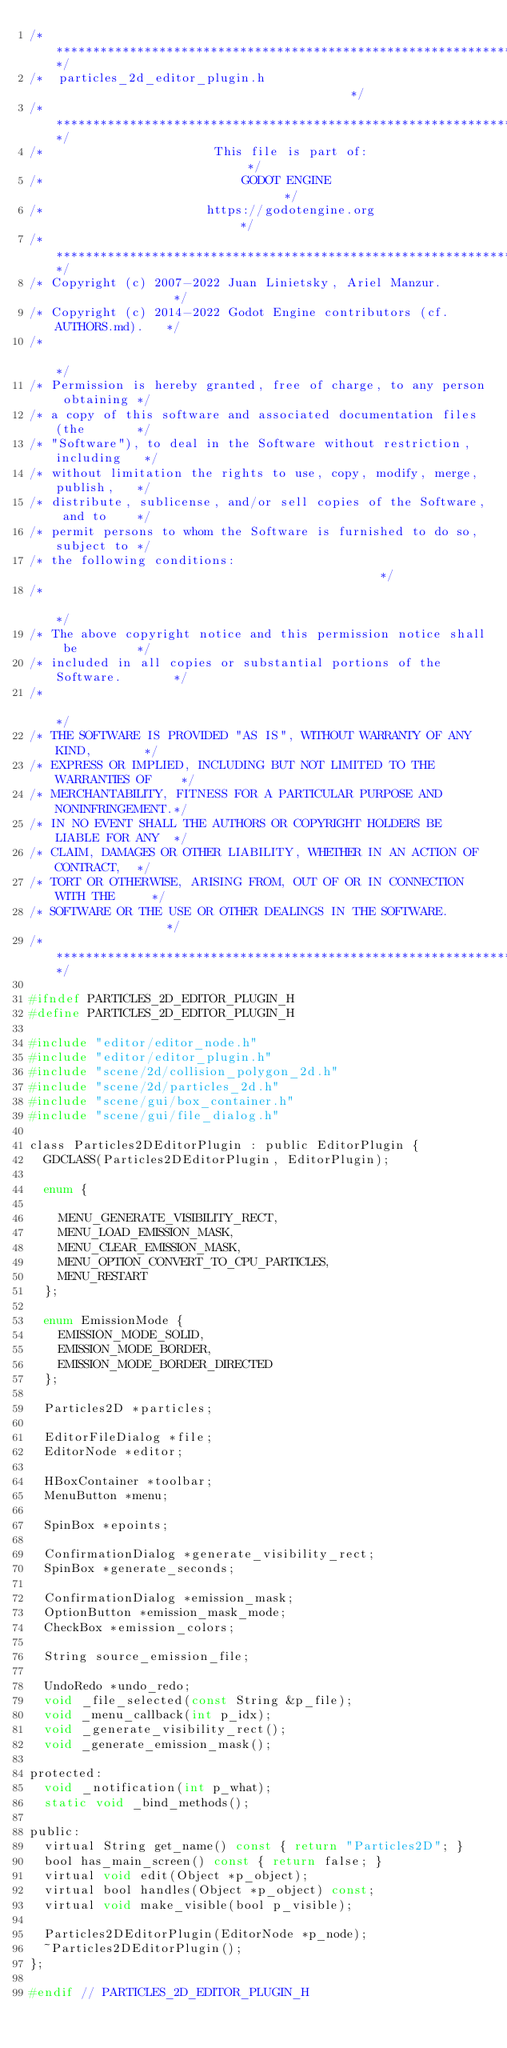Convert code to text. <code><loc_0><loc_0><loc_500><loc_500><_C_>/*************************************************************************/
/*  particles_2d_editor_plugin.h                                         */
/*************************************************************************/
/*                       This file is part of:                           */
/*                           GODOT ENGINE                                */
/*                      https://godotengine.org                          */
/*************************************************************************/
/* Copyright (c) 2007-2022 Juan Linietsky, Ariel Manzur.                 */
/* Copyright (c) 2014-2022 Godot Engine contributors (cf. AUTHORS.md).   */
/*                                                                       */
/* Permission is hereby granted, free of charge, to any person obtaining */
/* a copy of this software and associated documentation files (the       */
/* "Software"), to deal in the Software without restriction, including   */
/* without limitation the rights to use, copy, modify, merge, publish,   */
/* distribute, sublicense, and/or sell copies of the Software, and to    */
/* permit persons to whom the Software is furnished to do so, subject to */
/* the following conditions:                                             */
/*                                                                       */
/* The above copyright notice and this permission notice shall be        */
/* included in all copies or substantial portions of the Software.       */
/*                                                                       */
/* THE SOFTWARE IS PROVIDED "AS IS", WITHOUT WARRANTY OF ANY KIND,       */
/* EXPRESS OR IMPLIED, INCLUDING BUT NOT LIMITED TO THE WARRANTIES OF    */
/* MERCHANTABILITY, FITNESS FOR A PARTICULAR PURPOSE AND NONINFRINGEMENT.*/
/* IN NO EVENT SHALL THE AUTHORS OR COPYRIGHT HOLDERS BE LIABLE FOR ANY  */
/* CLAIM, DAMAGES OR OTHER LIABILITY, WHETHER IN AN ACTION OF CONTRACT,  */
/* TORT OR OTHERWISE, ARISING FROM, OUT OF OR IN CONNECTION WITH THE     */
/* SOFTWARE OR THE USE OR OTHER DEALINGS IN THE SOFTWARE.                */
/*************************************************************************/

#ifndef PARTICLES_2D_EDITOR_PLUGIN_H
#define PARTICLES_2D_EDITOR_PLUGIN_H

#include "editor/editor_node.h"
#include "editor/editor_plugin.h"
#include "scene/2d/collision_polygon_2d.h"
#include "scene/2d/particles_2d.h"
#include "scene/gui/box_container.h"
#include "scene/gui/file_dialog.h"

class Particles2DEditorPlugin : public EditorPlugin {
	GDCLASS(Particles2DEditorPlugin, EditorPlugin);

	enum {

		MENU_GENERATE_VISIBILITY_RECT,
		MENU_LOAD_EMISSION_MASK,
		MENU_CLEAR_EMISSION_MASK,
		MENU_OPTION_CONVERT_TO_CPU_PARTICLES,
		MENU_RESTART
	};

	enum EmissionMode {
		EMISSION_MODE_SOLID,
		EMISSION_MODE_BORDER,
		EMISSION_MODE_BORDER_DIRECTED
	};

	Particles2D *particles;

	EditorFileDialog *file;
	EditorNode *editor;

	HBoxContainer *toolbar;
	MenuButton *menu;

	SpinBox *epoints;

	ConfirmationDialog *generate_visibility_rect;
	SpinBox *generate_seconds;

	ConfirmationDialog *emission_mask;
	OptionButton *emission_mask_mode;
	CheckBox *emission_colors;

	String source_emission_file;

	UndoRedo *undo_redo;
	void _file_selected(const String &p_file);
	void _menu_callback(int p_idx);
	void _generate_visibility_rect();
	void _generate_emission_mask();

protected:
	void _notification(int p_what);
	static void _bind_methods();

public:
	virtual String get_name() const { return "Particles2D"; }
	bool has_main_screen() const { return false; }
	virtual void edit(Object *p_object);
	virtual bool handles(Object *p_object) const;
	virtual void make_visible(bool p_visible);

	Particles2DEditorPlugin(EditorNode *p_node);
	~Particles2DEditorPlugin();
};

#endif // PARTICLES_2D_EDITOR_PLUGIN_H
</code> 